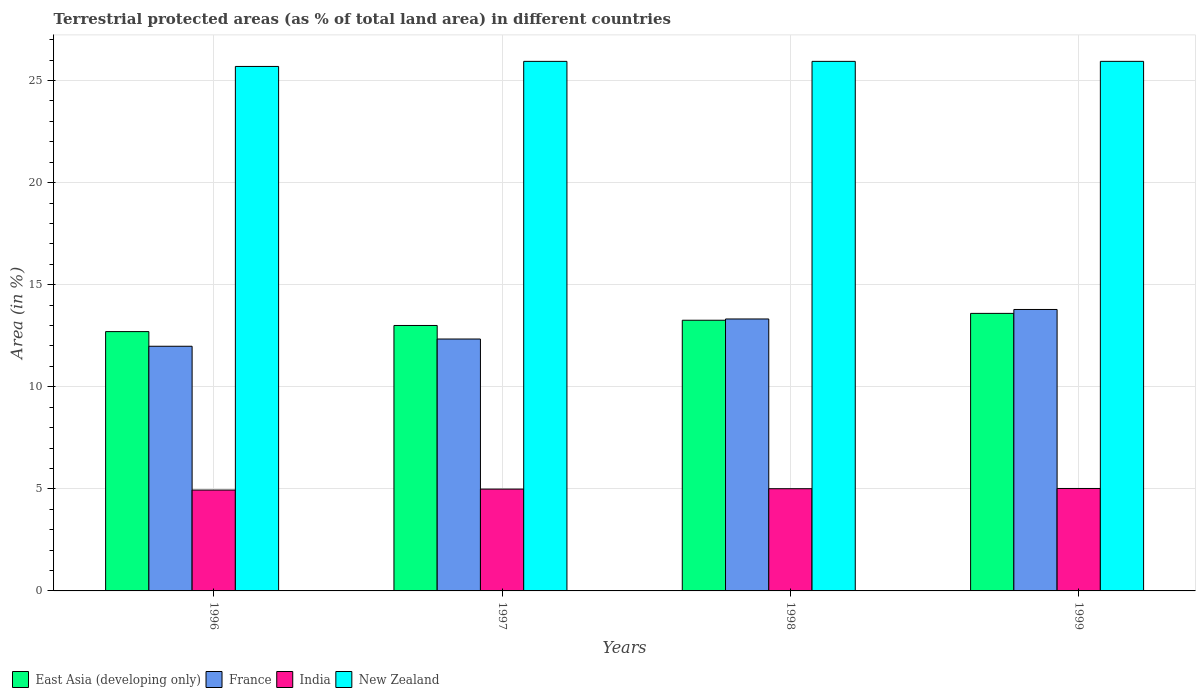How many groups of bars are there?
Your response must be concise. 4. Are the number of bars per tick equal to the number of legend labels?
Ensure brevity in your answer.  Yes. In how many cases, is the number of bars for a given year not equal to the number of legend labels?
Offer a very short reply. 0. What is the percentage of terrestrial protected land in New Zealand in 1996?
Keep it short and to the point. 25.69. Across all years, what is the maximum percentage of terrestrial protected land in New Zealand?
Provide a succinct answer. 25.94. Across all years, what is the minimum percentage of terrestrial protected land in New Zealand?
Offer a very short reply. 25.69. What is the total percentage of terrestrial protected land in France in the graph?
Offer a terse response. 51.43. What is the difference between the percentage of terrestrial protected land in New Zealand in 1996 and that in 1999?
Your answer should be compact. -0.25. What is the difference between the percentage of terrestrial protected land in New Zealand in 1998 and the percentage of terrestrial protected land in East Asia (developing only) in 1996?
Keep it short and to the point. 13.24. What is the average percentage of terrestrial protected land in India per year?
Your response must be concise. 4.99. In the year 1997, what is the difference between the percentage of terrestrial protected land in France and percentage of terrestrial protected land in New Zealand?
Provide a short and direct response. -13.6. What is the ratio of the percentage of terrestrial protected land in India in 1998 to that in 1999?
Make the answer very short. 1. What is the difference between the highest and the second highest percentage of terrestrial protected land in East Asia (developing only)?
Your response must be concise. 0.34. What is the difference between the highest and the lowest percentage of terrestrial protected land in India?
Your answer should be compact. 0.08. Is the sum of the percentage of terrestrial protected land in India in 1997 and 1999 greater than the maximum percentage of terrestrial protected land in East Asia (developing only) across all years?
Give a very brief answer. No. What does the 1st bar from the left in 1999 represents?
Provide a short and direct response. East Asia (developing only). What does the 3rd bar from the right in 1996 represents?
Your answer should be very brief. France. Is it the case that in every year, the sum of the percentage of terrestrial protected land in France and percentage of terrestrial protected land in New Zealand is greater than the percentage of terrestrial protected land in East Asia (developing only)?
Give a very brief answer. Yes. Are all the bars in the graph horizontal?
Offer a very short reply. No. How many years are there in the graph?
Ensure brevity in your answer.  4. What is the difference between two consecutive major ticks on the Y-axis?
Your answer should be compact. 5. Are the values on the major ticks of Y-axis written in scientific E-notation?
Make the answer very short. No. Does the graph contain grids?
Your response must be concise. Yes. How are the legend labels stacked?
Ensure brevity in your answer.  Horizontal. What is the title of the graph?
Offer a terse response. Terrestrial protected areas (as % of total land area) in different countries. What is the label or title of the X-axis?
Your response must be concise. Years. What is the label or title of the Y-axis?
Ensure brevity in your answer.  Area (in %). What is the Area (in %) of East Asia (developing only) in 1996?
Your answer should be compact. 12.7. What is the Area (in %) of France in 1996?
Offer a terse response. 11.98. What is the Area (in %) in India in 1996?
Offer a very short reply. 4.94. What is the Area (in %) of New Zealand in 1996?
Make the answer very short. 25.69. What is the Area (in %) in East Asia (developing only) in 1997?
Provide a short and direct response. 13. What is the Area (in %) in France in 1997?
Offer a very short reply. 12.34. What is the Area (in %) of India in 1997?
Your response must be concise. 4.99. What is the Area (in %) in New Zealand in 1997?
Make the answer very short. 25.94. What is the Area (in %) in East Asia (developing only) in 1998?
Your answer should be very brief. 13.26. What is the Area (in %) of France in 1998?
Give a very brief answer. 13.32. What is the Area (in %) of India in 1998?
Provide a succinct answer. 5.01. What is the Area (in %) of New Zealand in 1998?
Your response must be concise. 25.94. What is the Area (in %) in East Asia (developing only) in 1999?
Provide a short and direct response. 13.59. What is the Area (in %) in France in 1999?
Provide a succinct answer. 13.78. What is the Area (in %) in India in 1999?
Offer a terse response. 5.02. What is the Area (in %) of New Zealand in 1999?
Offer a terse response. 25.94. Across all years, what is the maximum Area (in %) in East Asia (developing only)?
Ensure brevity in your answer.  13.59. Across all years, what is the maximum Area (in %) in France?
Make the answer very short. 13.78. Across all years, what is the maximum Area (in %) in India?
Ensure brevity in your answer.  5.02. Across all years, what is the maximum Area (in %) in New Zealand?
Keep it short and to the point. 25.94. Across all years, what is the minimum Area (in %) of East Asia (developing only)?
Give a very brief answer. 12.7. Across all years, what is the minimum Area (in %) in France?
Your answer should be compact. 11.98. Across all years, what is the minimum Area (in %) of India?
Offer a terse response. 4.94. Across all years, what is the minimum Area (in %) in New Zealand?
Provide a succinct answer. 25.69. What is the total Area (in %) of East Asia (developing only) in the graph?
Your answer should be compact. 52.55. What is the total Area (in %) of France in the graph?
Offer a terse response. 51.43. What is the total Area (in %) in India in the graph?
Give a very brief answer. 19.95. What is the total Area (in %) in New Zealand in the graph?
Your answer should be very brief. 103.5. What is the difference between the Area (in %) of East Asia (developing only) in 1996 and that in 1997?
Your answer should be very brief. -0.3. What is the difference between the Area (in %) of France in 1996 and that in 1997?
Provide a succinct answer. -0.35. What is the difference between the Area (in %) in India in 1996 and that in 1997?
Give a very brief answer. -0.05. What is the difference between the Area (in %) of New Zealand in 1996 and that in 1997?
Make the answer very short. -0.25. What is the difference between the Area (in %) of East Asia (developing only) in 1996 and that in 1998?
Make the answer very short. -0.56. What is the difference between the Area (in %) in France in 1996 and that in 1998?
Your answer should be very brief. -1.34. What is the difference between the Area (in %) of India in 1996 and that in 1998?
Your answer should be compact. -0.07. What is the difference between the Area (in %) of New Zealand in 1996 and that in 1998?
Your response must be concise. -0.25. What is the difference between the Area (in %) in East Asia (developing only) in 1996 and that in 1999?
Offer a terse response. -0.89. What is the difference between the Area (in %) of France in 1996 and that in 1999?
Provide a short and direct response. -1.8. What is the difference between the Area (in %) in India in 1996 and that in 1999?
Your answer should be very brief. -0.08. What is the difference between the Area (in %) in New Zealand in 1996 and that in 1999?
Your response must be concise. -0.25. What is the difference between the Area (in %) of East Asia (developing only) in 1997 and that in 1998?
Provide a succinct answer. -0.26. What is the difference between the Area (in %) of France in 1997 and that in 1998?
Offer a very short reply. -0.98. What is the difference between the Area (in %) in India in 1997 and that in 1998?
Make the answer very short. -0.02. What is the difference between the Area (in %) of East Asia (developing only) in 1997 and that in 1999?
Ensure brevity in your answer.  -0.59. What is the difference between the Area (in %) of France in 1997 and that in 1999?
Keep it short and to the point. -1.45. What is the difference between the Area (in %) of India in 1997 and that in 1999?
Ensure brevity in your answer.  -0.03. What is the difference between the Area (in %) of New Zealand in 1997 and that in 1999?
Provide a short and direct response. -0. What is the difference between the Area (in %) of East Asia (developing only) in 1998 and that in 1999?
Offer a very short reply. -0.34. What is the difference between the Area (in %) of France in 1998 and that in 1999?
Ensure brevity in your answer.  -0.47. What is the difference between the Area (in %) in India in 1998 and that in 1999?
Keep it short and to the point. -0.01. What is the difference between the Area (in %) in New Zealand in 1998 and that in 1999?
Offer a terse response. -0. What is the difference between the Area (in %) of East Asia (developing only) in 1996 and the Area (in %) of France in 1997?
Ensure brevity in your answer.  0.36. What is the difference between the Area (in %) in East Asia (developing only) in 1996 and the Area (in %) in India in 1997?
Offer a very short reply. 7.71. What is the difference between the Area (in %) in East Asia (developing only) in 1996 and the Area (in %) in New Zealand in 1997?
Ensure brevity in your answer.  -13.24. What is the difference between the Area (in %) in France in 1996 and the Area (in %) in India in 1997?
Offer a terse response. 7. What is the difference between the Area (in %) in France in 1996 and the Area (in %) in New Zealand in 1997?
Keep it short and to the point. -13.95. What is the difference between the Area (in %) of India in 1996 and the Area (in %) of New Zealand in 1997?
Ensure brevity in your answer.  -21. What is the difference between the Area (in %) in East Asia (developing only) in 1996 and the Area (in %) in France in 1998?
Make the answer very short. -0.62. What is the difference between the Area (in %) in East Asia (developing only) in 1996 and the Area (in %) in India in 1998?
Give a very brief answer. 7.7. What is the difference between the Area (in %) in East Asia (developing only) in 1996 and the Area (in %) in New Zealand in 1998?
Ensure brevity in your answer.  -13.24. What is the difference between the Area (in %) of France in 1996 and the Area (in %) of India in 1998?
Offer a terse response. 6.98. What is the difference between the Area (in %) in France in 1996 and the Area (in %) in New Zealand in 1998?
Give a very brief answer. -13.95. What is the difference between the Area (in %) in India in 1996 and the Area (in %) in New Zealand in 1998?
Offer a terse response. -21. What is the difference between the Area (in %) in East Asia (developing only) in 1996 and the Area (in %) in France in 1999?
Make the answer very short. -1.08. What is the difference between the Area (in %) in East Asia (developing only) in 1996 and the Area (in %) in India in 1999?
Give a very brief answer. 7.68. What is the difference between the Area (in %) of East Asia (developing only) in 1996 and the Area (in %) of New Zealand in 1999?
Offer a very short reply. -13.24. What is the difference between the Area (in %) in France in 1996 and the Area (in %) in India in 1999?
Offer a terse response. 6.97. What is the difference between the Area (in %) in France in 1996 and the Area (in %) in New Zealand in 1999?
Keep it short and to the point. -13.95. What is the difference between the Area (in %) in India in 1996 and the Area (in %) in New Zealand in 1999?
Your response must be concise. -21. What is the difference between the Area (in %) in East Asia (developing only) in 1997 and the Area (in %) in France in 1998?
Your answer should be very brief. -0.32. What is the difference between the Area (in %) in East Asia (developing only) in 1997 and the Area (in %) in India in 1998?
Your answer should be compact. 8. What is the difference between the Area (in %) in East Asia (developing only) in 1997 and the Area (in %) in New Zealand in 1998?
Ensure brevity in your answer.  -12.94. What is the difference between the Area (in %) of France in 1997 and the Area (in %) of India in 1998?
Provide a short and direct response. 7.33. What is the difference between the Area (in %) in France in 1997 and the Area (in %) in New Zealand in 1998?
Your answer should be compact. -13.6. What is the difference between the Area (in %) in India in 1997 and the Area (in %) in New Zealand in 1998?
Offer a very short reply. -20.95. What is the difference between the Area (in %) in East Asia (developing only) in 1997 and the Area (in %) in France in 1999?
Make the answer very short. -0.78. What is the difference between the Area (in %) of East Asia (developing only) in 1997 and the Area (in %) of India in 1999?
Offer a terse response. 7.98. What is the difference between the Area (in %) in East Asia (developing only) in 1997 and the Area (in %) in New Zealand in 1999?
Provide a succinct answer. -12.94. What is the difference between the Area (in %) in France in 1997 and the Area (in %) in India in 1999?
Provide a succinct answer. 7.32. What is the difference between the Area (in %) of France in 1997 and the Area (in %) of New Zealand in 1999?
Give a very brief answer. -13.6. What is the difference between the Area (in %) of India in 1997 and the Area (in %) of New Zealand in 1999?
Your answer should be very brief. -20.95. What is the difference between the Area (in %) of East Asia (developing only) in 1998 and the Area (in %) of France in 1999?
Keep it short and to the point. -0.53. What is the difference between the Area (in %) of East Asia (developing only) in 1998 and the Area (in %) of India in 1999?
Keep it short and to the point. 8.24. What is the difference between the Area (in %) in East Asia (developing only) in 1998 and the Area (in %) in New Zealand in 1999?
Make the answer very short. -12.68. What is the difference between the Area (in %) in France in 1998 and the Area (in %) in India in 1999?
Provide a succinct answer. 8.3. What is the difference between the Area (in %) in France in 1998 and the Area (in %) in New Zealand in 1999?
Your response must be concise. -12.62. What is the difference between the Area (in %) in India in 1998 and the Area (in %) in New Zealand in 1999?
Offer a very short reply. -20.93. What is the average Area (in %) of East Asia (developing only) per year?
Offer a very short reply. 13.14. What is the average Area (in %) in France per year?
Keep it short and to the point. 12.86. What is the average Area (in %) of India per year?
Provide a succinct answer. 4.99. What is the average Area (in %) of New Zealand per year?
Offer a terse response. 25.88. In the year 1996, what is the difference between the Area (in %) of East Asia (developing only) and Area (in %) of France?
Your response must be concise. 0.72. In the year 1996, what is the difference between the Area (in %) of East Asia (developing only) and Area (in %) of India?
Your answer should be compact. 7.76. In the year 1996, what is the difference between the Area (in %) in East Asia (developing only) and Area (in %) in New Zealand?
Provide a short and direct response. -12.99. In the year 1996, what is the difference between the Area (in %) in France and Area (in %) in India?
Make the answer very short. 7.04. In the year 1996, what is the difference between the Area (in %) in France and Area (in %) in New Zealand?
Your response must be concise. -13.71. In the year 1996, what is the difference between the Area (in %) of India and Area (in %) of New Zealand?
Ensure brevity in your answer.  -20.75. In the year 1997, what is the difference between the Area (in %) of East Asia (developing only) and Area (in %) of France?
Provide a succinct answer. 0.66. In the year 1997, what is the difference between the Area (in %) of East Asia (developing only) and Area (in %) of India?
Your answer should be very brief. 8.01. In the year 1997, what is the difference between the Area (in %) of East Asia (developing only) and Area (in %) of New Zealand?
Provide a short and direct response. -12.94. In the year 1997, what is the difference between the Area (in %) of France and Area (in %) of India?
Offer a very short reply. 7.35. In the year 1997, what is the difference between the Area (in %) of France and Area (in %) of New Zealand?
Provide a short and direct response. -13.6. In the year 1997, what is the difference between the Area (in %) in India and Area (in %) in New Zealand?
Ensure brevity in your answer.  -20.95. In the year 1998, what is the difference between the Area (in %) in East Asia (developing only) and Area (in %) in France?
Your answer should be very brief. -0.06. In the year 1998, what is the difference between the Area (in %) of East Asia (developing only) and Area (in %) of India?
Your answer should be very brief. 8.25. In the year 1998, what is the difference between the Area (in %) of East Asia (developing only) and Area (in %) of New Zealand?
Provide a succinct answer. -12.68. In the year 1998, what is the difference between the Area (in %) of France and Area (in %) of India?
Your response must be concise. 8.31. In the year 1998, what is the difference between the Area (in %) in France and Area (in %) in New Zealand?
Provide a short and direct response. -12.62. In the year 1998, what is the difference between the Area (in %) of India and Area (in %) of New Zealand?
Ensure brevity in your answer.  -20.93. In the year 1999, what is the difference between the Area (in %) in East Asia (developing only) and Area (in %) in France?
Offer a very short reply. -0.19. In the year 1999, what is the difference between the Area (in %) in East Asia (developing only) and Area (in %) in India?
Make the answer very short. 8.58. In the year 1999, what is the difference between the Area (in %) in East Asia (developing only) and Area (in %) in New Zealand?
Offer a very short reply. -12.34. In the year 1999, what is the difference between the Area (in %) of France and Area (in %) of India?
Provide a succinct answer. 8.77. In the year 1999, what is the difference between the Area (in %) in France and Area (in %) in New Zealand?
Ensure brevity in your answer.  -12.15. In the year 1999, what is the difference between the Area (in %) in India and Area (in %) in New Zealand?
Your answer should be compact. -20.92. What is the ratio of the Area (in %) of East Asia (developing only) in 1996 to that in 1997?
Offer a very short reply. 0.98. What is the ratio of the Area (in %) in France in 1996 to that in 1997?
Make the answer very short. 0.97. What is the ratio of the Area (in %) in East Asia (developing only) in 1996 to that in 1998?
Make the answer very short. 0.96. What is the ratio of the Area (in %) in France in 1996 to that in 1998?
Ensure brevity in your answer.  0.9. What is the ratio of the Area (in %) in India in 1996 to that in 1998?
Ensure brevity in your answer.  0.99. What is the ratio of the Area (in %) in East Asia (developing only) in 1996 to that in 1999?
Give a very brief answer. 0.93. What is the ratio of the Area (in %) of France in 1996 to that in 1999?
Your answer should be compact. 0.87. What is the ratio of the Area (in %) of India in 1996 to that in 1999?
Offer a terse response. 0.98. What is the ratio of the Area (in %) in East Asia (developing only) in 1997 to that in 1998?
Offer a very short reply. 0.98. What is the ratio of the Area (in %) in France in 1997 to that in 1998?
Your answer should be compact. 0.93. What is the ratio of the Area (in %) in East Asia (developing only) in 1997 to that in 1999?
Offer a very short reply. 0.96. What is the ratio of the Area (in %) of France in 1997 to that in 1999?
Keep it short and to the point. 0.9. What is the ratio of the Area (in %) in India in 1997 to that in 1999?
Provide a succinct answer. 0.99. What is the ratio of the Area (in %) of East Asia (developing only) in 1998 to that in 1999?
Your response must be concise. 0.98. What is the ratio of the Area (in %) of France in 1998 to that in 1999?
Give a very brief answer. 0.97. What is the difference between the highest and the second highest Area (in %) in East Asia (developing only)?
Ensure brevity in your answer.  0.34. What is the difference between the highest and the second highest Area (in %) in France?
Your answer should be very brief. 0.47. What is the difference between the highest and the second highest Area (in %) of India?
Keep it short and to the point. 0.01. What is the difference between the highest and the second highest Area (in %) of New Zealand?
Provide a succinct answer. 0. What is the difference between the highest and the lowest Area (in %) in East Asia (developing only)?
Give a very brief answer. 0.89. What is the difference between the highest and the lowest Area (in %) of France?
Keep it short and to the point. 1.8. What is the difference between the highest and the lowest Area (in %) of India?
Give a very brief answer. 0.08. What is the difference between the highest and the lowest Area (in %) of New Zealand?
Give a very brief answer. 0.25. 